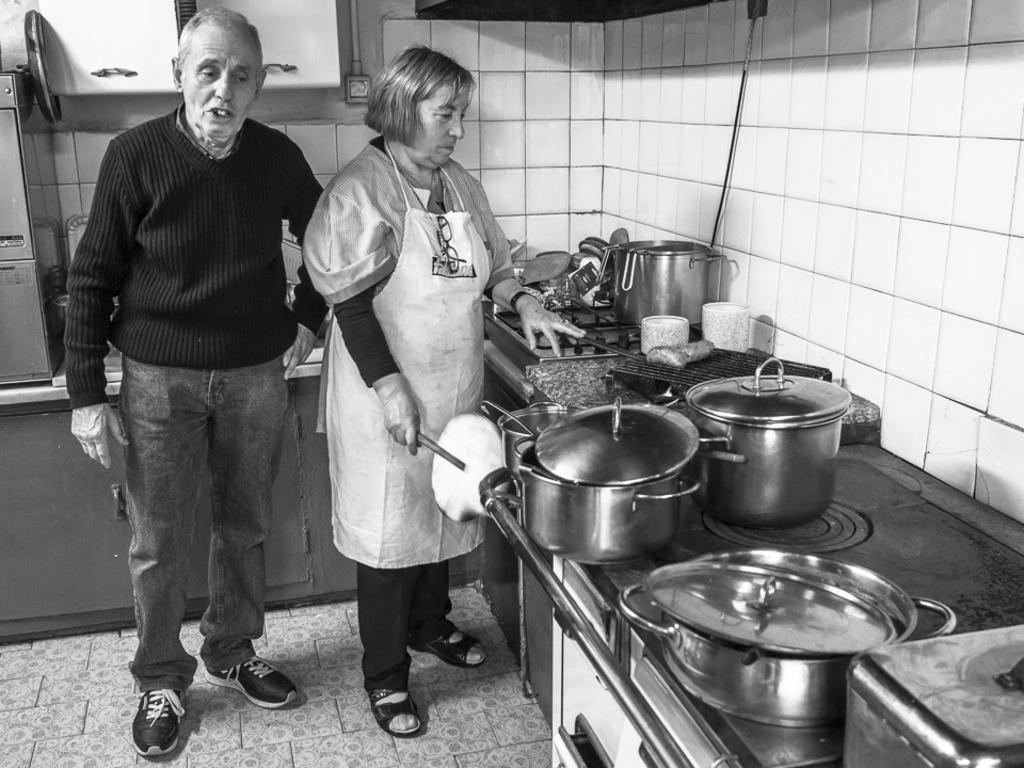Could you give a brief overview of what you see in this image? In this picture there is a woman standing and holding the object and there is a man standing. On the right side of the image there are utensils on the table. At the back there are objects on the table. At the top there are cupboards and there is a pipe on the wall. At the bottom there is a floor. 